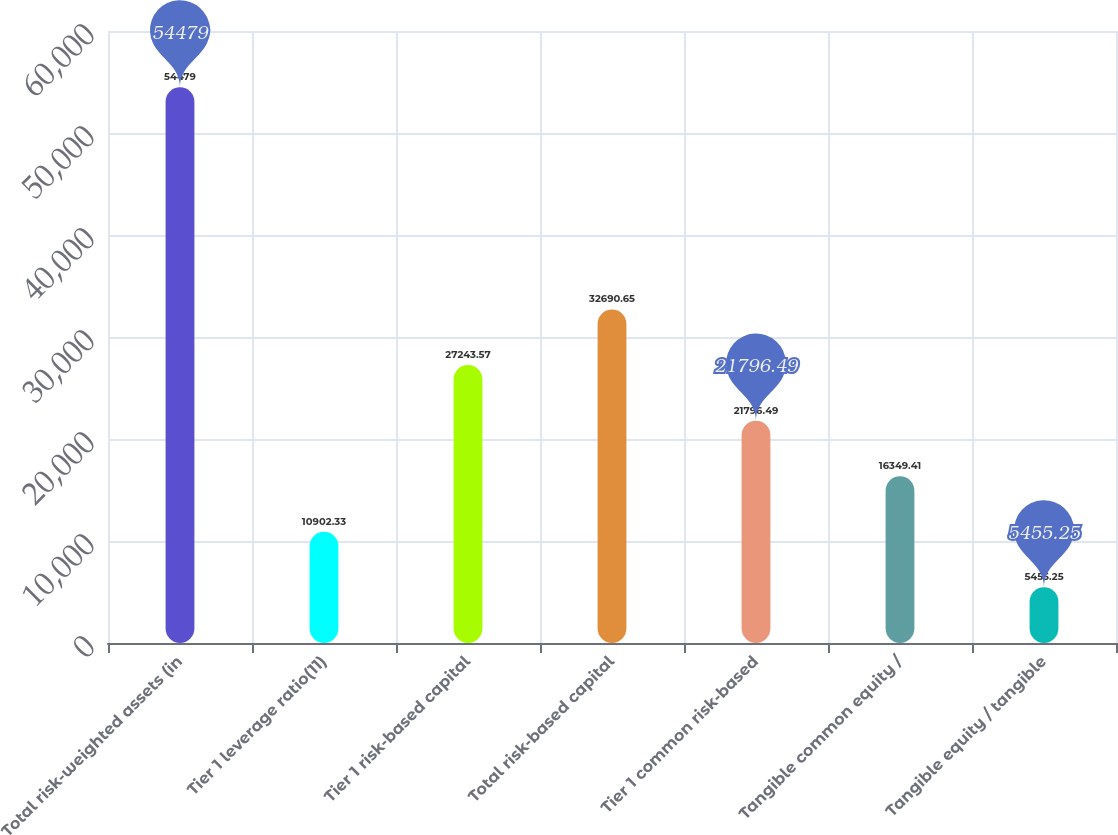Convert chart. <chart><loc_0><loc_0><loc_500><loc_500><bar_chart><fcel>Total risk-weighted assets (in<fcel>Tier 1 leverage ratio(11)<fcel>Tier 1 risk-based capital<fcel>Total risk-based capital<fcel>Tier 1 common risk-based<fcel>Tangible common equity /<fcel>Tangible equity / tangible<nl><fcel>54479<fcel>10902.3<fcel>27243.6<fcel>32690.7<fcel>21796.5<fcel>16349.4<fcel>5455.25<nl></chart> 